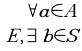<formula> <loc_0><loc_0><loc_500><loc_500>\forall a \in A \\ E , \exists b \in S</formula> 